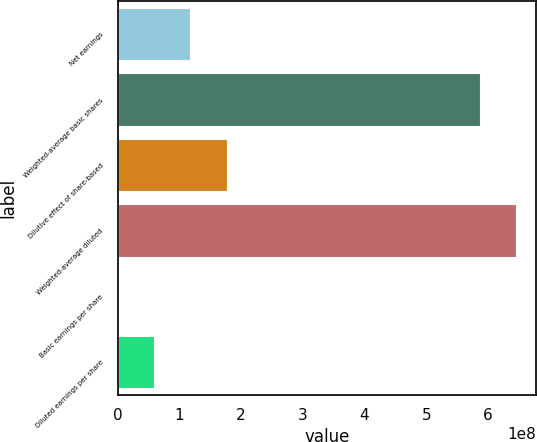<chart> <loc_0><loc_0><loc_500><loc_500><bar_chart><fcel>Net earnings<fcel>Weighted-average basic shares<fcel>Dilutive effect of share-based<fcel>Weighted-average diluted<fcel>Basic earnings per share<fcel>Diluted earnings per share<nl><fcel>1.17738e+08<fcel>5.86526e+08<fcel>1.76607e+08<fcel>6.45395e+08<fcel>1.96<fcel>5.88692e+07<nl></chart> 